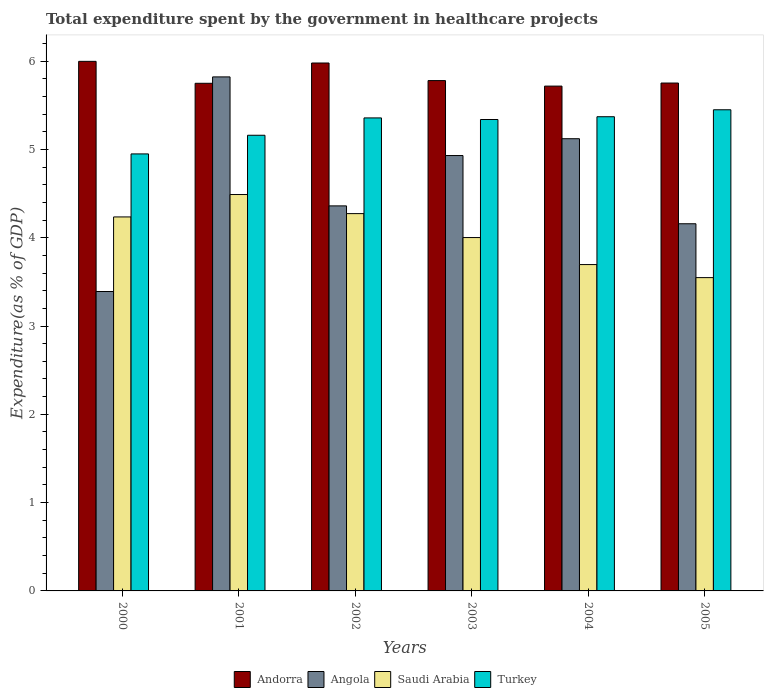How many different coloured bars are there?
Provide a succinct answer. 4. Are the number of bars on each tick of the X-axis equal?
Provide a short and direct response. Yes. How many bars are there on the 5th tick from the right?
Your answer should be very brief. 4. What is the label of the 5th group of bars from the left?
Your response must be concise. 2004. In how many cases, is the number of bars for a given year not equal to the number of legend labels?
Make the answer very short. 0. What is the total expenditure spent by the government in healthcare projects in Turkey in 2005?
Provide a short and direct response. 5.45. Across all years, what is the maximum total expenditure spent by the government in healthcare projects in Saudi Arabia?
Give a very brief answer. 4.49. Across all years, what is the minimum total expenditure spent by the government in healthcare projects in Turkey?
Your answer should be compact. 4.95. In which year was the total expenditure spent by the government in healthcare projects in Andorra maximum?
Make the answer very short. 2000. What is the total total expenditure spent by the government in healthcare projects in Turkey in the graph?
Offer a terse response. 31.62. What is the difference between the total expenditure spent by the government in healthcare projects in Angola in 2000 and that in 2004?
Keep it short and to the point. -1.73. What is the difference between the total expenditure spent by the government in healthcare projects in Saudi Arabia in 2002 and the total expenditure spent by the government in healthcare projects in Turkey in 2004?
Keep it short and to the point. -1.1. What is the average total expenditure spent by the government in healthcare projects in Andorra per year?
Keep it short and to the point. 5.83. In the year 2001, what is the difference between the total expenditure spent by the government in healthcare projects in Andorra and total expenditure spent by the government in healthcare projects in Angola?
Your answer should be compact. -0.07. What is the ratio of the total expenditure spent by the government in healthcare projects in Saudi Arabia in 2003 to that in 2005?
Your response must be concise. 1.13. Is the difference between the total expenditure spent by the government in healthcare projects in Andorra in 2000 and 2003 greater than the difference between the total expenditure spent by the government in healthcare projects in Angola in 2000 and 2003?
Offer a terse response. Yes. What is the difference between the highest and the second highest total expenditure spent by the government in healthcare projects in Saudi Arabia?
Your response must be concise. 0.22. What is the difference between the highest and the lowest total expenditure spent by the government in healthcare projects in Saudi Arabia?
Ensure brevity in your answer.  0.94. Is the sum of the total expenditure spent by the government in healthcare projects in Andorra in 2002 and 2005 greater than the maximum total expenditure spent by the government in healthcare projects in Angola across all years?
Ensure brevity in your answer.  Yes. What does the 1st bar from the left in 2000 represents?
Your answer should be very brief. Andorra. What does the 2nd bar from the right in 2001 represents?
Offer a very short reply. Saudi Arabia. Is it the case that in every year, the sum of the total expenditure spent by the government in healthcare projects in Angola and total expenditure spent by the government in healthcare projects in Turkey is greater than the total expenditure spent by the government in healthcare projects in Saudi Arabia?
Give a very brief answer. Yes. Are all the bars in the graph horizontal?
Your answer should be compact. No. How many years are there in the graph?
Ensure brevity in your answer.  6. What is the difference between two consecutive major ticks on the Y-axis?
Make the answer very short. 1. Are the values on the major ticks of Y-axis written in scientific E-notation?
Offer a very short reply. No. Does the graph contain any zero values?
Offer a very short reply. No. How are the legend labels stacked?
Make the answer very short. Horizontal. What is the title of the graph?
Provide a short and direct response. Total expenditure spent by the government in healthcare projects. Does "Grenada" appear as one of the legend labels in the graph?
Ensure brevity in your answer.  No. What is the label or title of the Y-axis?
Offer a very short reply. Expenditure(as % of GDP). What is the Expenditure(as % of GDP) of Andorra in 2000?
Provide a short and direct response. 6. What is the Expenditure(as % of GDP) in Angola in 2000?
Give a very brief answer. 3.39. What is the Expenditure(as % of GDP) in Saudi Arabia in 2000?
Offer a very short reply. 4.24. What is the Expenditure(as % of GDP) of Turkey in 2000?
Keep it short and to the point. 4.95. What is the Expenditure(as % of GDP) in Andorra in 2001?
Your response must be concise. 5.75. What is the Expenditure(as % of GDP) of Angola in 2001?
Provide a succinct answer. 5.82. What is the Expenditure(as % of GDP) in Saudi Arabia in 2001?
Provide a short and direct response. 4.49. What is the Expenditure(as % of GDP) of Turkey in 2001?
Offer a terse response. 5.16. What is the Expenditure(as % of GDP) of Andorra in 2002?
Offer a terse response. 5.98. What is the Expenditure(as % of GDP) in Angola in 2002?
Keep it short and to the point. 4.36. What is the Expenditure(as % of GDP) in Saudi Arabia in 2002?
Provide a succinct answer. 4.27. What is the Expenditure(as % of GDP) of Turkey in 2002?
Provide a succinct answer. 5.36. What is the Expenditure(as % of GDP) of Andorra in 2003?
Your answer should be very brief. 5.78. What is the Expenditure(as % of GDP) in Angola in 2003?
Provide a succinct answer. 4.93. What is the Expenditure(as % of GDP) in Saudi Arabia in 2003?
Provide a short and direct response. 4. What is the Expenditure(as % of GDP) in Turkey in 2003?
Ensure brevity in your answer.  5.34. What is the Expenditure(as % of GDP) of Andorra in 2004?
Your response must be concise. 5.72. What is the Expenditure(as % of GDP) in Angola in 2004?
Your answer should be very brief. 5.12. What is the Expenditure(as % of GDP) of Saudi Arabia in 2004?
Offer a terse response. 3.7. What is the Expenditure(as % of GDP) of Turkey in 2004?
Your answer should be very brief. 5.37. What is the Expenditure(as % of GDP) in Andorra in 2005?
Your answer should be compact. 5.75. What is the Expenditure(as % of GDP) of Angola in 2005?
Give a very brief answer. 4.16. What is the Expenditure(as % of GDP) in Saudi Arabia in 2005?
Your response must be concise. 3.55. What is the Expenditure(as % of GDP) in Turkey in 2005?
Give a very brief answer. 5.45. Across all years, what is the maximum Expenditure(as % of GDP) in Andorra?
Ensure brevity in your answer.  6. Across all years, what is the maximum Expenditure(as % of GDP) in Angola?
Your response must be concise. 5.82. Across all years, what is the maximum Expenditure(as % of GDP) in Saudi Arabia?
Give a very brief answer. 4.49. Across all years, what is the maximum Expenditure(as % of GDP) in Turkey?
Provide a succinct answer. 5.45. Across all years, what is the minimum Expenditure(as % of GDP) of Andorra?
Provide a succinct answer. 5.72. Across all years, what is the minimum Expenditure(as % of GDP) of Angola?
Provide a succinct answer. 3.39. Across all years, what is the minimum Expenditure(as % of GDP) in Saudi Arabia?
Give a very brief answer. 3.55. Across all years, what is the minimum Expenditure(as % of GDP) of Turkey?
Your response must be concise. 4.95. What is the total Expenditure(as % of GDP) of Andorra in the graph?
Keep it short and to the point. 34.97. What is the total Expenditure(as % of GDP) in Angola in the graph?
Provide a succinct answer. 27.78. What is the total Expenditure(as % of GDP) of Saudi Arabia in the graph?
Your response must be concise. 24.24. What is the total Expenditure(as % of GDP) in Turkey in the graph?
Provide a short and direct response. 31.62. What is the difference between the Expenditure(as % of GDP) in Andorra in 2000 and that in 2001?
Your response must be concise. 0.25. What is the difference between the Expenditure(as % of GDP) in Angola in 2000 and that in 2001?
Provide a short and direct response. -2.43. What is the difference between the Expenditure(as % of GDP) in Saudi Arabia in 2000 and that in 2001?
Your answer should be compact. -0.25. What is the difference between the Expenditure(as % of GDP) of Turkey in 2000 and that in 2001?
Your answer should be compact. -0.21. What is the difference between the Expenditure(as % of GDP) of Andorra in 2000 and that in 2002?
Keep it short and to the point. 0.02. What is the difference between the Expenditure(as % of GDP) of Angola in 2000 and that in 2002?
Make the answer very short. -0.97. What is the difference between the Expenditure(as % of GDP) in Saudi Arabia in 2000 and that in 2002?
Provide a short and direct response. -0.04. What is the difference between the Expenditure(as % of GDP) in Turkey in 2000 and that in 2002?
Your answer should be very brief. -0.41. What is the difference between the Expenditure(as % of GDP) of Andorra in 2000 and that in 2003?
Ensure brevity in your answer.  0.22. What is the difference between the Expenditure(as % of GDP) of Angola in 2000 and that in 2003?
Give a very brief answer. -1.54. What is the difference between the Expenditure(as % of GDP) in Saudi Arabia in 2000 and that in 2003?
Your answer should be very brief. 0.23. What is the difference between the Expenditure(as % of GDP) in Turkey in 2000 and that in 2003?
Give a very brief answer. -0.39. What is the difference between the Expenditure(as % of GDP) of Andorra in 2000 and that in 2004?
Give a very brief answer. 0.28. What is the difference between the Expenditure(as % of GDP) of Angola in 2000 and that in 2004?
Offer a terse response. -1.73. What is the difference between the Expenditure(as % of GDP) in Saudi Arabia in 2000 and that in 2004?
Provide a short and direct response. 0.54. What is the difference between the Expenditure(as % of GDP) of Turkey in 2000 and that in 2004?
Offer a very short reply. -0.42. What is the difference between the Expenditure(as % of GDP) of Andorra in 2000 and that in 2005?
Your answer should be very brief. 0.25. What is the difference between the Expenditure(as % of GDP) of Angola in 2000 and that in 2005?
Keep it short and to the point. -0.77. What is the difference between the Expenditure(as % of GDP) in Saudi Arabia in 2000 and that in 2005?
Your answer should be compact. 0.69. What is the difference between the Expenditure(as % of GDP) of Turkey in 2000 and that in 2005?
Provide a short and direct response. -0.5. What is the difference between the Expenditure(as % of GDP) in Andorra in 2001 and that in 2002?
Give a very brief answer. -0.23. What is the difference between the Expenditure(as % of GDP) in Angola in 2001 and that in 2002?
Your response must be concise. 1.46. What is the difference between the Expenditure(as % of GDP) in Saudi Arabia in 2001 and that in 2002?
Offer a terse response. 0.22. What is the difference between the Expenditure(as % of GDP) in Turkey in 2001 and that in 2002?
Make the answer very short. -0.2. What is the difference between the Expenditure(as % of GDP) in Andorra in 2001 and that in 2003?
Ensure brevity in your answer.  -0.03. What is the difference between the Expenditure(as % of GDP) in Angola in 2001 and that in 2003?
Offer a very short reply. 0.89. What is the difference between the Expenditure(as % of GDP) in Saudi Arabia in 2001 and that in 2003?
Provide a short and direct response. 0.49. What is the difference between the Expenditure(as % of GDP) in Turkey in 2001 and that in 2003?
Give a very brief answer. -0.18. What is the difference between the Expenditure(as % of GDP) of Andorra in 2001 and that in 2004?
Your response must be concise. 0.03. What is the difference between the Expenditure(as % of GDP) of Angola in 2001 and that in 2004?
Your answer should be very brief. 0.7. What is the difference between the Expenditure(as % of GDP) in Saudi Arabia in 2001 and that in 2004?
Give a very brief answer. 0.79. What is the difference between the Expenditure(as % of GDP) in Turkey in 2001 and that in 2004?
Ensure brevity in your answer.  -0.21. What is the difference between the Expenditure(as % of GDP) in Andorra in 2001 and that in 2005?
Your answer should be very brief. -0. What is the difference between the Expenditure(as % of GDP) of Angola in 2001 and that in 2005?
Provide a succinct answer. 1.66. What is the difference between the Expenditure(as % of GDP) in Saudi Arabia in 2001 and that in 2005?
Your answer should be compact. 0.94. What is the difference between the Expenditure(as % of GDP) of Turkey in 2001 and that in 2005?
Offer a terse response. -0.29. What is the difference between the Expenditure(as % of GDP) in Andorra in 2002 and that in 2003?
Ensure brevity in your answer.  0.2. What is the difference between the Expenditure(as % of GDP) in Angola in 2002 and that in 2003?
Ensure brevity in your answer.  -0.57. What is the difference between the Expenditure(as % of GDP) in Saudi Arabia in 2002 and that in 2003?
Provide a short and direct response. 0.27. What is the difference between the Expenditure(as % of GDP) of Turkey in 2002 and that in 2003?
Provide a short and direct response. 0.02. What is the difference between the Expenditure(as % of GDP) in Andorra in 2002 and that in 2004?
Offer a very short reply. 0.26. What is the difference between the Expenditure(as % of GDP) in Angola in 2002 and that in 2004?
Offer a terse response. -0.76. What is the difference between the Expenditure(as % of GDP) in Saudi Arabia in 2002 and that in 2004?
Make the answer very short. 0.58. What is the difference between the Expenditure(as % of GDP) in Turkey in 2002 and that in 2004?
Your answer should be compact. -0.01. What is the difference between the Expenditure(as % of GDP) in Andorra in 2002 and that in 2005?
Ensure brevity in your answer.  0.23. What is the difference between the Expenditure(as % of GDP) of Angola in 2002 and that in 2005?
Make the answer very short. 0.2. What is the difference between the Expenditure(as % of GDP) of Saudi Arabia in 2002 and that in 2005?
Make the answer very short. 0.72. What is the difference between the Expenditure(as % of GDP) in Turkey in 2002 and that in 2005?
Offer a terse response. -0.09. What is the difference between the Expenditure(as % of GDP) of Andorra in 2003 and that in 2004?
Ensure brevity in your answer.  0.06. What is the difference between the Expenditure(as % of GDP) of Angola in 2003 and that in 2004?
Give a very brief answer. -0.19. What is the difference between the Expenditure(as % of GDP) of Saudi Arabia in 2003 and that in 2004?
Provide a short and direct response. 0.31. What is the difference between the Expenditure(as % of GDP) of Turkey in 2003 and that in 2004?
Your answer should be compact. -0.03. What is the difference between the Expenditure(as % of GDP) of Andorra in 2003 and that in 2005?
Keep it short and to the point. 0.03. What is the difference between the Expenditure(as % of GDP) of Angola in 2003 and that in 2005?
Ensure brevity in your answer.  0.77. What is the difference between the Expenditure(as % of GDP) of Saudi Arabia in 2003 and that in 2005?
Your answer should be very brief. 0.45. What is the difference between the Expenditure(as % of GDP) in Turkey in 2003 and that in 2005?
Your answer should be very brief. -0.11. What is the difference between the Expenditure(as % of GDP) of Andorra in 2004 and that in 2005?
Make the answer very short. -0.03. What is the difference between the Expenditure(as % of GDP) in Angola in 2004 and that in 2005?
Your answer should be compact. 0.96. What is the difference between the Expenditure(as % of GDP) of Saudi Arabia in 2004 and that in 2005?
Your response must be concise. 0.15. What is the difference between the Expenditure(as % of GDP) in Turkey in 2004 and that in 2005?
Provide a succinct answer. -0.08. What is the difference between the Expenditure(as % of GDP) of Andorra in 2000 and the Expenditure(as % of GDP) of Angola in 2001?
Ensure brevity in your answer.  0.18. What is the difference between the Expenditure(as % of GDP) in Andorra in 2000 and the Expenditure(as % of GDP) in Saudi Arabia in 2001?
Ensure brevity in your answer.  1.51. What is the difference between the Expenditure(as % of GDP) of Andorra in 2000 and the Expenditure(as % of GDP) of Turkey in 2001?
Offer a very short reply. 0.84. What is the difference between the Expenditure(as % of GDP) of Angola in 2000 and the Expenditure(as % of GDP) of Saudi Arabia in 2001?
Give a very brief answer. -1.1. What is the difference between the Expenditure(as % of GDP) in Angola in 2000 and the Expenditure(as % of GDP) in Turkey in 2001?
Your answer should be compact. -1.77. What is the difference between the Expenditure(as % of GDP) of Saudi Arabia in 2000 and the Expenditure(as % of GDP) of Turkey in 2001?
Keep it short and to the point. -0.92. What is the difference between the Expenditure(as % of GDP) in Andorra in 2000 and the Expenditure(as % of GDP) in Angola in 2002?
Make the answer very short. 1.64. What is the difference between the Expenditure(as % of GDP) of Andorra in 2000 and the Expenditure(as % of GDP) of Saudi Arabia in 2002?
Make the answer very short. 1.72. What is the difference between the Expenditure(as % of GDP) in Andorra in 2000 and the Expenditure(as % of GDP) in Turkey in 2002?
Give a very brief answer. 0.64. What is the difference between the Expenditure(as % of GDP) in Angola in 2000 and the Expenditure(as % of GDP) in Saudi Arabia in 2002?
Offer a very short reply. -0.88. What is the difference between the Expenditure(as % of GDP) of Angola in 2000 and the Expenditure(as % of GDP) of Turkey in 2002?
Offer a very short reply. -1.97. What is the difference between the Expenditure(as % of GDP) in Saudi Arabia in 2000 and the Expenditure(as % of GDP) in Turkey in 2002?
Provide a short and direct response. -1.12. What is the difference between the Expenditure(as % of GDP) of Andorra in 2000 and the Expenditure(as % of GDP) of Angola in 2003?
Give a very brief answer. 1.07. What is the difference between the Expenditure(as % of GDP) in Andorra in 2000 and the Expenditure(as % of GDP) in Saudi Arabia in 2003?
Keep it short and to the point. 2. What is the difference between the Expenditure(as % of GDP) of Andorra in 2000 and the Expenditure(as % of GDP) of Turkey in 2003?
Your answer should be very brief. 0.66. What is the difference between the Expenditure(as % of GDP) in Angola in 2000 and the Expenditure(as % of GDP) in Saudi Arabia in 2003?
Keep it short and to the point. -0.61. What is the difference between the Expenditure(as % of GDP) in Angola in 2000 and the Expenditure(as % of GDP) in Turkey in 2003?
Offer a very short reply. -1.95. What is the difference between the Expenditure(as % of GDP) in Saudi Arabia in 2000 and the Expenditure(as % of GDP) in Turkey in 2003?
Ensure brevity in your answer.  -1.1. What is the difference between the Expenditure(as % of GDP) of Andorra in 2000 and the Expenditure(as % of GDP) of Angola in 2004?
Ensure brevity in your answer.  0.88. What is the difference between the Expenditure(as % of GDP) of Andorra in 2000 and the Expenditure(as % of GDP) of Saudi Arabia in 2004?
Offer a very short reply. 2.3. What is the difference between the Expenditure(as % of GDP) of Andorra in 2000 and the Expenditure(as % of GDP) of Turkey in 2004?
Ensure brevity in your answer.  0.63. What is the difference between the Expenditure(as % of GDP) of Angola in 2000 and the Expenditure(as % of GDP) of Saudi Arabia in 2004?
Offer a terse response. -0.31. What is the difference between the Expenditure(as % of GDP) in Angola in 2000 and the Expenditure(as % of GDP) in Turkey in 2004?
Your answer should be very brief. -1.98. What is the difference between the Expenditure(as % of GDP) in Saudi Arabia in 2000 and the Expenditure(as % of GDP) in Turkey in 2004?
Your response must be concise. -1.13. What is the difference between the Expenditure(as % of GDP) in Andorra in 2000 and the Expenditure(as % of GDP) in Angola in 2005?
Give a very brief answer. 1.84. What is the difference between the Expenditure(as % of GDP) in Andorra in 2000 and the Expenditure(as % of GDP) in Saudi Arabia in 2005?
Keep it short and to the point. 2.45. What is the difference between the Expenditure(as % of GDP) of Andorra in 2000 and the Expenditure(as % of GDP) of Turkey in 2005?
Give a very brief answer. 0.55. What is the difference between the Expenditure(as % of GDP) in Angola in 2000 and the Expenditure(as % of GDP) in Saudi Arabia in 2005?
Give a very brief answer. -0.16. What is the difference between the Expenditure(as % of GDP) of Angola in 2000 and the Expenditure(as % of GDP) of Turkey in 2005?
Make the answer very short. -2.06. What is the difference between the Expenditure(as % of GDP) in Saudi Arabia in 2000 and the Expenditure(as % of GDP) in Turkey in 2005?
Your answer should be very brief. -1.21. What is the difference between the Expenditure(as % of GDP) of Andorra in 2001 and the Expenditure(as % of GDP) of Angola in 2002?
Keep it short and to the point. 1.39. What is the difference between the Expenditure(as % of GDP) in Andorra in 2001 and the Expenditure(as % of GDP) in Saudi Arabia in 2002?
Offer a very short reply. 1.48. What is the difference between the Expenditure(as % of GDP) of Andorra in 2001 and the Expenditure(as % of GDP) of Turkey in 2002?
Make the answer very short. 0.39. What is the difference between the Expenditure(as % of GDP) of Angola in 2001 and the Expenditure(as % of GDP) of Saudi Arabia in 2002?
Make the answer very short. 1.55. What is the difference between the Expenditure(as % of GDP) of Angola in 2001 and the Expenditure(as % of GDP) of Turkey in 2002?
Provide a short and direct response. 0.46. What is the difference between the Expenditure(as % of GDP) in Saudi Arabia in 2001 and the Expenditure(as % of GDP) in Turkey in 2002?
Provide a short and direct response. -0.87. What is the difference between the Expenditure(as % of GDP) in Andorra in 2001 and the Expenditure(as % of GDP) in Angola in 2003?
Your answer should be compact. 0.82. What is the difference between the Expenditure(as % of GDP) in Andorra in 2001 and the Expenditure(as % of GDP) in Saudi Arabia in 2003?
Offer a terse response. 1.75. What is the difference between the Expenditure(as % of GDP) of Andorra in 2001 and the Expenditure(as % of GDP) of Turkey in 2003?
Give a very brief answer. 0.41. What is the difference between the Expenditure(as % of GDP) of Angola in 2001 and the Expenditure(as % of GDP) of Saudi Arabia in 2003?
Your answer should be very brief. 1.82. What is the difference between the Expenditure(as % of GDP) of Angola in 2001 and the Expenditure(as % of GDP) of Turkey in 2003?
Make the answer very short. 0.48. What is the difference between the Expenditure(as % of GDP) of Saudi Arabia in 2001 and the Expenditure(as % of GDP) of Turkey in 2003?
Offer a very short reply. -0.85. What is the difference between the Expenditure(as % of GDP) of Andorra in 2001 and the Expenditure(as % of GDP) of Angola in 2004?
Your answer should be very brief. 0.63. What is the difference between the Expenditure(as % of GDP) in Andorra in 2001 and the Expenditure(as % of GDP) in Saudi Arabia in 2004?
Your response must be concise. 2.05. What is the difference between the Expenditure(as % of GDP) of Andorra in 2001 and the Expenditure(as % of GDP) of Turkey in 2004?
Offer a very short reply. 0.38. What is the difference between the Expenditure(as % of GDP) of Angola in 2001 and the Expenditure(as % of GDP) of Saudi Arabia in 2004?
Provide a succinct answer. 2.13. What is the difference between the Expenditure(as % of GDP) in Angola in 2001 and the Expenditure(as % of GDP) in Turkey in 2004?
Provide a short and direct response. 0.45. What is the difference between the Expenditure(as % of GDP) of Saudi Arabia in 2001 and the Expenditure(as % of GDP) of Turkey in 2004?
Make the answer very short. -0.88. What is the difference between the Expenditure(as % of GDP) of Andorra in 2001 and the Expenditure(as % of GDP) of Angola in 2005?
Give a very brief answer. 1.59. What is the difference between the Expenditure(as % of GDP) of Andorra in 2001 and the Expenditure(as % of GDP) of Saudi Arabia in 2005?
Make the answer very short. 2.2. What is the difference between the Expenditure(as % of GDP) in Angola in 2001 and the Expenditure(as % of GDP) in Saudi Arabia in 2005?
Provide a short and direct response. 2.27. What is the difference between the Expenditure(as % of GDP) in Angola in 2001 and the Expenditure(as % of GDP) in Turkey in 2005?
Offer a very short reply. 0.37. What is the difference between the Expenditure(as % of GDP) in Saudi Arabia in 2001 and the Expenditure(as % of GDP) in Turkey in 2005?
Your answer should be very brief. -0.96. What is the difference between the Expenditure(as % of GDP) in Andorra in 2002 and the Expenditure(as % of GDP) in Angola in 2003?
Offer a very short reply. 1.05. What is the difference between the Expenditure(as % of GDP) in Andorra in 2002 and the Expenditure(as % of GDP) in Saudi Arabia in 2003?
Your answer should be very brief. 1.98. What is the difference between the Expenditure(as % of GDP) of Andorra in 2002 and the Expenditure(as % of GDP) of Turkey in 2003?
Your answer should be very brief. 0.64. What is the difference between the Expenditure(as % of GDP) in Angola in 2002 and the Expenditure(as % of GDP) in Saudi Arabia in 2003?
Your answer should be very brief. 0.36. What is the difference between the Expenditure(as % of GDP) of Angola in 2002 and the Expenditure(as % of GDP) of Turkey in 2003?
Ensure brevity in your answer.  -0.98. What is the difference between the Expenditure(as % of GDP) in Saudi Arabia in 2002 and the Expenditure(as % of GDP) in Turkey in 2003?
Your response must be concise. -1.07. What is the difference between the Expenditure(as % of GDP) of Andorra in 2002 and the Expenditure(as % of GDP) of Angola in 2004?
Provide a succinct answer. 0.86. What is the difference between the Expenditure(as % of GDP) in Andorra in 2002 and the Expenditure(as % of GDP) in Saudi Arabia in 2004?
Ensure brevity in your answer.  2.28. What is the difference between the Expenditure(as % of GDP) of Andorra in 2002 and the Expenditure(as % of GDP) of Turkey in 2004?
Make the answer very short. 0.61. What is the difference between the Expenditure(as % of GDP) in Angola in 2002 and the Expenditure(as % of GDP) in Saudi Arabia in 2004?
Keep it short and to the point. 0.66. What is the difference between the Expenditure(as % of GDP) of Angola in 2002 and the Expenditure(as % of GDP) of Turkey in 2004?
Provide a short and direct response. -1.01. What is the difference between the Expenditure(as % of GDP) in Saudi Arabia in 2002 and the Expenditure(as % of GDP) in Turkey in 2004?
Provide a short and direct response. -1.1. What is the difference between the Expenditure(as % of GDP) in Andorra in 2002 and the Expenditure(as % of GDP) in Angola in 2005?
Provide a short and direct response. 1.82. What is the difference between the Expenditure(as % of GDP) in Andorra in 2002 and the Expenditure(as % of GDP) in Saudi Arabia in 2005?
Ensure brevity in your answer.  2.43. What is the difference between the Expenditure(as % of GDP) in Andorra in 2002 and the Expenditure(as % of GDP) in Turkey in 2005?
Offer a very short reply. 0.53. What is the difference between the Expenditure(as % of GDP) of Angola in 2002 and the Expenditure(as % of GDP) of Saudi Arabia in 2005?
Keep it short and to the point. 0.81. What is the difference between the Expenditure(as % of GDP) in Angola in 2002 and the Expenditure(as % of GDP) in Turkey in 2005?
Provide a short and direct response. -1.09. What is the difference between the Expenditure(as % of GDP) of Saudi Arabia in 2002 and the Expenditure(as % of GDP) of Turkey in 2005?
Your answer should be very brief. -1.18. What is the difference between the Expenditure(as % of GDP) of Andorra in 2003 and the Expenditure(as % of GDP) of Angola in 2004?
Provide a short and direct response. 0.66. What is the difference between the Expenditure(as % of GDP) in Andorra in 2003 and the Expenditure(as % of GDP) in Saudi Arabia in 2004?
Make the answer very short. 2.08. What is the difference between the Expenditure(as % of GDP) of Andorra in 2003 and the Expenditure(as % of GDP) of Turkey in 2004?
Make the answer very short. 0.41. What is the difference between the Expenditure(as % of GDP) of Angola in 2003 and the Expenditure(as % of GDP) of Saudi Arabia in 2004?
Keep it short and to the point. 1.23. What is the difference between the Expenditure(as % of GDP) in Angola in 2003 and the Expenditure(as % of GDP) in Turkey in 2004?
Keep it short and to the point. -0.44. What is the difference between the Expenditure(as % of GDP) of Saudi Arabia in 2003 and the Expenditure(as % of GDP) of Turkey in 2004?
Your response must be concise. -1.37. What is the difference between the Expenditure(as % of GDP) of Andorra in 2003 and the Expenditure(as % of GDP) of Angola in 2005?
Your answer should be very brief. 1.62. What is the difference between the Expenditure(as % of GDP) of Andorra in 2003 and the Expenditure(as % of GDP) of Saudi Arabia in 2005?
Your answer should be very brief. 2.23. What is the difference between the Expenditure(as % of GDP) in Andorra in 2003 and the Expenditure(as % of GDP) in Turkey in 2005?
Offer a very short reply. 0.33. What is the difference between the Expenditure(as % of GDP) of Angola in 2003 and the Expenditure(as % of GDP) of Saudi Arabia in 2005?
Provide a short and direct response. 1.38. What is the difference between the Expenditure(as % of GDP) in Angola in 2003 and the Expenditure(as % of GDP) in Turkey in 2005?
Keep it short and to the point. -0.52. What is the difference between the Expenditure(as % of GDP) in Saudi Arabia in 2003 and the Expenditure(as % of GDP) in Turkey in 2005?
Provide a short and direct response. -1.45. What is the difference between the Expenditure(as % of GDP) of Andorra in 2004 and the Expenditure(as % of GDP) of Angola in 2005?
Offer a terse response. 1.56. What is the difference between the Expenditure(as % of GDP) of Andorra in 2004 and the Expenditure(as % of GDP) of Saudi Arabia in 2005?
Provide a succinct answer. 2.17. What is the difference between the Expenditure(as % of GDP) in Andorra in 2004 and the Expenditure(as % of GDP) in Turkey in 2005?
Your answer should be compact. 0.27. What is the difference between the Expenditure(as % of GDP) in Angola in 2004 and the Expenditure(as % of GDP) in Saudi Arabia in 2005?
Provide a succinct answer. 1.57. What is the difference between the Expenditure(as % of GDP) in Angola in 2004 and the Expenditure(as % of GDP) in Turkey in 2005?
Offer a very short reply. -0.33. What is the difference between the Expenditure(as % of GDP) in Saudi Arabia in 2004 and the Expenditure(as % of GDP) in Turkey in 2005?
Your answer should be very brief. -1.75. What is the average Expenditure(as % of GDP) in Andorra per year?
Provide a short and direct response. 5.83. What is the average Expenditure(as % of GDP) in Angola per year?
Your answer should be compact. 4.63. What is the average Expenditure(as % of GDP) in Saudi Arabia per year?
Give a very brief answer. 4.04. What is the average Expenditure(as % of GDP) of Turkey per year?
Your answer should be compact. 5.27. In the year 2000, what is the difference between the Expenditure(as % of GDP) in Andorra and Expenditure(as % of GDP) in Angola?
Provide a short and direct response. 2.61. In the year 2000, what is the difference between the Expenditure(as % of GDP) of Andorra and Expenditure(as % of GDP) of Saudi Arabia?
Keep it short and to the point. 1.76. In the year 2000, what is the difference between the Expenditure(as % of GDP) of Andorra and Expenditure(as % of GDP) of Turkey?
Keep it short and to the point. 1.05. In the year 2000, what is the difference between the Expenditure(as % of GDP) in Angola and Expenditure(as % of GDP) in Saudi Arabia?
Offer a terse response. -0.84. In the year 2000, what is the difference between the Expenditure(as % of GDP) of Angola and Expenditure(as % of GDP) of Turkey?
Provide a short and direct response. -1.56. In the year 2000, what is the difference between the Expenditure(as % of GDP) in Saudi Arabia and Expenditure(as % of GDP) in Turkey?
Your response must be concise. -0.71. In the year 2001, what is the difference between the Expenditure(as % of GDP) of Andorra and Expenditure(as % of GDP) of Angola?
Your response must be concise. -0.07. In the year 2001, what is the difference between the Expenditure(as % of GDP) of Andorra and Expenditure(as % of GDP) of Saudi Arabia?
Offer a terse response. 1.26. In the year 2001, what is the difference between the Expenditure(as % of GDP) in Andorra and Expenditure(as % of GDP) in Turkey?
Ensure brevity in your answer.  0.59. In the year 2001, what is the difference between the Expenditure(as % of GDP) of Angola and Expenditure(as % of GDP) of Saudi Arabia?
Offer a very short reply. 1.33. In the year 2001, what is the difference between the Expenditure(as % of GDP) in Angola and Expenditure(as % of GDP) in Turkey?
Provide a succinct answer. 0.66. In the year 2001, what is the difference between the Expenditure(as % of GDP) of Saudi Arabia and Expenditure(as % of GDP) of Turkey?
Your answer should be compact. -0.67. In the year 2002, what is the difference between the Expenditure(as % of GDP) of Andorra and Expenditure(as % of GDP) of Angola?
Offer a very short reply. 1.62. In the year 2002, what is the difference between the Expenditure(as % of GDP) of Andorra and Expenditure(as % of GDP) of Saudi Arabia?
Offer a terse response. 1.71. In the year 2002, what is the difference between the Expenditure(as % of GDP) of Andorra and Expenditure(as % of GDP) of Turkey?
Offer a terse response. 0.62. In the year 2002, what is the difference between the Expenditure(as % of GDP) in Angola and Expenditure(as % of GDP) in Saudi Arabia?
Keep it short and to the point. 0.09. In the year 2002, what is the difference between the Expenditure(as % of GDP) of Angola and Expenditure(as % of GDP) of Turkey?
Your response must be concise. -1. In the year 2002, what is the difference between the Expenditure(as % of GDP) of Saudi Arabia and Expenditure(as % of GDP) of Turkey?
Provide a succinct answer. -1.08. In the year 2003, what is the difference between the Expenditure(as % of GDP) of Andorra and Expenditure(as % of GDP) of Angola?
Ensure brevity in your answer.  0.85. In the year 2003, what is the difference between the Expenditure(as % of GDP) in Andorra and Expenditure(as % of GDP) in Saudi Arabia?
Ensure brevity in your answer.  1.78. In the year 2003, what is the difference between the Expenditure(as % of GDP) of Andorra and Expenditure(as % of GDP) of Turkey?
Provide a succinct answer. 0.44. In the year 2003, what is the difference between the Expenditure(as % of GDP) in Angola and Expenditure(as % of GDP) in Saudi Arabia?
Offer a very short reply. 0.93. In the year 2003, what is the difference between the Expenditure(as % of GDP) in Angola and Expenditure(as % of GDP) in Turkey?
Offer a terse response. -0.41. In the year 2003, what is the difference between the Expenditure(as % of GDP) of Saudi Arabia and Expenditure(as % of GDP) of Turkey?
Offer a very short reply. -1.34. In the year 2004, what is the difference between the Expenditure(as % of GDP) of Andorra and Expenditure(as % of GDP) of Angola?
Offer a very short reply. 0.6. In the year 2004, what is the difference between the Expenditure(as % of GDP) in Andorra and Expenditure(as % of GDP) in Saudi Arabia?
Your answer should be compact. 2.02. In the year 2004, what is the difference between the Expenditure(as % of GDP) of Andorra and Expenditure(as % of GDP) of Turkey?
Offer a very short reply. 0.35. In the year 2004, what is the difference between the Expenditure(as % of GDP) of Angola and Expenditure(as % of GDP) of Saudi Arabia?
Offer a very short reply. 1.43. In the year 2004, what is the difference between the Expenditure(as % of GDP) in Angola and Expenditure(as % of GDP) in Turkey?
Your answer should be very brief. -0.25. In the year 2004, what is the difference between the Expenditure(as % of GDP) of Saudi Arabia and Expenditure(as % of GDP) of Turkey?
Your response must be concise. -1.67. In the year 2005, what is the difference between the Expenditure(as % of GDP) in Andorra and Expenditure(as % of GDP) in Angola?
Provide a succinct answer. 1.59. In the year 2005, what is the difference between the Expenditure(as % of GDP) of Andorra and Expenditure(as % of GDP) of Saudi Arabia?
Make the answer very short. 2.2. In the year 2005, what is the difference between the Expenditure(as % of GDP) in Andorra and Expenditure(as % of GDP) in Turkey?
Your response must be concise. 0.3. In the year 2005, what is the difference between the Expenditure(as % of GDP) in Angola and Expenditure(as % of GDP) in Saudi Arabia?
Provide a short and direct response. 0.61. In the year 2005, what is the difference between the Expenditure(as % of GDP) in Angola and Expenditure(as % of GDP) in Turkey?
Offer a very short reply. -1.29. In the year 2005, what is the difference between the Expenditure(as % of GDP) of Saudi Arabia and Expenditure(as % of GDP) of Turkey?
Your answer should be very brief. -1.9. What is the ratio of the Expenditure(as % of GDP) of Andorra in 2000 to that in 2001?
Make the answer very short. 1.04. What is the ratio of the Expenditure(as % of GDP) in Angola in 2000 to that in 2001?
Provide a succinct answer. 0.58. What is the ratio of the Expenditure(as % of GDP) in Saudi Arabia in 2000 to that in 2001?
Give a very brief answer. 0.94. What is the ratio of the Expenditure(as % of GDP) of Turkey in 2000 to that in 2001?
Give a very brief answer. 0.96. What is the ratio of the Expenditure(as % of GDP) in Angola in 2000 to that in 2002?
Your answer should be very brief. 0.78. What is the ratio of the Expenditure(as % of GDP) of Turkey in 2000 to that in 2002?
Make the answer very short. 0.92. What is the ratio of the Expenditure(as % of GDP) of Andorra in 2000 to that in 2003?
Provide a short and direct response. 1.04. What is the ratio of the Expenditure(as % of GDP) of Angola in 2000 to that in 2003?
Offer a terse response. 0.69. What is the ratio of the Expenditure(as % of GDP) of Saudi Arabia in 2000 to that in 2003?
Your answer should be very brief. 1.06. What is the ratio of the Expenditure(as % of GDP) in Turkey in 2000 to that in 2003?
Your answer should be very brief. 0.93. What is the ratio of the Expenditure(as % of GDP) of Andorra in 2000 to that in 2004?
Ensure brevity in your answer.  1.05. What is the ratio of the Expenditure(as % of GDP) of Angola in 2000 to that in 2004?
Make the answer very short. 0.66. What is the ratio of the Expenditure(as % of GDP) of Saudi Arabia in 2000 to that in 2004?
Keep it short and to the point. 1.15. What is the ratio of the Expenditure(as % of GDP) in Turkey in 2000 to that in 2004?
Provide a short and direct response. 0.92. What is the ratio of the Expenditure(as % of GDP) in Andorra in 2000 to that in 2005?
Make the answer very short. 1.04. What is the ratio of the Expenditure(as % of GDP) of Angola in 2000 to that in 2005?
Ensure brevity in your answer.  0.82. What is the ratio of the Expenditure(as % of GDP) in Saudi Arabia in 2000 to that in 2005?
Provide a succinct answer. 1.19. What is the ratio of the Expenditure(as % of GDP) of Turkey in 2000 to that in 2005?
Your answer should be very brief. 0.91. What is the ratio of the Expenditure(as % of GDP) of Andorra in 2001 to that in 2002?
Offer a terse response. 0.96. What is the ratio of the Expenditure(as % of GDP) in Angola in 2001 to that in 2002?
Keep it short and to the point. 1.33. What is the ratio of the Expenditure(as % of GDP) in Saudi Arabia in 2001 to that in 2002?
Provide a succinct answer. 1.05. What is the ratio of the Expenditure(as % of GDP) of Turkey in 2001 to that in 2002?
Provide a succinct answer. 0.96. What is the ratio of the Expenditure(as % of GDP) of Andorra in 2001 to that in 2003?
Your answer should be very brief. 0.99. What is the ratio of the Expenditure(as % of GDP) of Angola in 2001 to that in 2003?
Offer a terse response. 1.18. What is the ratio of the Expenditure(as % of GDP) of Saudi Arabia in 2001 to that in 2003?
Your answer should be very brief. 1.12. What is the ratio of the Expenditure(as % of GDP) in Turkey in 2001 to that in 2003?
Offer a very short reply. 0.97. What is the ratio of the Expenditure(as % of GDP) in Andorra in 2001 to that in 2004?
Provide a short and direct response. 1.01. What is the ratio of the Expenditure(as % of GDP) of Angola in 2001 to that in 2004?
Offer a terse response. 1.14. What is the ratio of the Expenditure(as % of GDP) of Saudi Arabia in 2001 to that in 2004?
Make the answer very short. 1.21. What is the ratio of the Expenditure(as % of GDP) in Turkey in 2001 to that in 2004?
Offer a very short reply. 0.96. What is the ratio of the Expenditure(as % of GDP) in Andorra in 2001 to that in 2005?
Make the answer very short. 1. What is the ratio of the Expenditure(as % of GDP) of Angola in 2001 to that in 2005?
Provide a short and direct response. 1.4. What is the ratio of the Expenditure(as % of GDP) of Saudi Arabia in 2001 to that in 2005?
Provide a succinct answer. 1.27. What is the ratio of the Expenditure(as % of GDP) in Turkey in 2001 to that in 2005?
Offer a very short reply. 0.95. What is the ratio of the Expenditure(as % of GDP) in Andorra in 2002 to that in 2003?
Give a very brief answer. 1.03. What is the ratio of the Expenditure(as % of GDP) in Angola in 2002 to that in 2003?
Ensure brevity in your answer.  0.88. What is the ratio of the Expenditure(as % of GDP) of Saudi Arabia in 2002 to that in 2003?
Your answer should be compact. 1.07. What is the ratio of the Expenditure(as % of GDP) of Andorra in 2002 to that in 2004?
Give a very brief answer. 1.05. What is the ratio of the Expenditure(as % of GDP) of Angola in 2002 to that in 2004?
Keep it short and to the point. 0.85. What is the ratio of the Expenditure(as % of GDP) of Saudi Arabia in 2002 to that in 2004?
Give a very brief answer. 1.16. What is the ratio of the Expenditure(as % of GDP) of Andorra in 2002 to that in 2005?
Ensure brevity in your answer.  1.04. What is the ratio of the Expenditure(as % of GDP) in Angola in 2002 to that in 2005?
Your answer should be compact. 1.05. What is the ratio of the Expenditure(as % of GDP) of Saudi Arabia in 2002 to that in 2005?
Provide a short and direct response. 1.2. What is the ratio of the Expenditure(as % of GDP) of Turkey in 2002 to that in 2005?
Provide a succinct answer. 0.98. What is the ratio of the Expenditure(as % of GDP) in Andorra in 2003 to that in 2004?
Your answer should be very brief. 1.01. What is the ratio of the Expenditure(as % of GDP) of Angola in 2003 to that in 2004?
Your response must be concise. 0.96. What is the ratio of the Expenditure(as % of GDP) of Saudi Arabia in 2003 to that in 2004?
Provide a short and direct response. 1.08. What is the ratio of the Expenditure(as % of GDP) in Angola in 2003 to that in 2005?
Make the answer very short. 1.19. What is the ratio of the Expenditure(as % of GDP) of Saudi Arabia in 2003 to that in 2005?
Offer a terse response. 1.13. What is the ratio of the Expenditure(as % of GDP) in Turkey in 2003 to that in 2005?
Give a very brief answer. 0.98. What is the ratio of the Expenditure(as % of GDP) in Andorra in 2004 to that in 2005?
Your answer should be compact. 0.99. What is the ratio of the Expenditure(as % of GDP) of Angola in 2004 to that in 2005?
Give a very brief answer. 1.23. What is the ratio of the Expenditure(as % of GDP) in Saudi Arabia in 2004 to that in 2005?
Make the answer very short. 1.04. What is the ratio of the Expenditure(as % of GDP) of Turkey in 2004 to that in 2005?
Give a very brief answer. 0.99. What is the difference between the highest and the second highest Expenditure(as % of GDP) in Andorra?
Your answer should be very brief. 0.02. What is the difference between the highest and the second highest Expenditure(as % of GDP) of Saudi Arabia?
Ensure brevity in your answer.  0.22. What is the difference between the highest and the second highest Expenditure(as % of GDP) of Turkey?
Your response must be concise. 0.08. What is the difference between the highest and the lowest Expenditure(as % of GDP) in Andorra?
Your answer should be very brief. 0.28. What is the difference between the highest and the lowest Expenditure(as % of GDP) of Angola?
Offer a very short reply. 2.43. What is the difference between the highest and the lowest Expenditure(as % of GDP) of Saudi Arabia?
Give a very brief answer. 0.94. What is the difference between the highest and the lowest Expenditure(as % of GDP) in Turkey?
Your response must be concise. 0.5. 